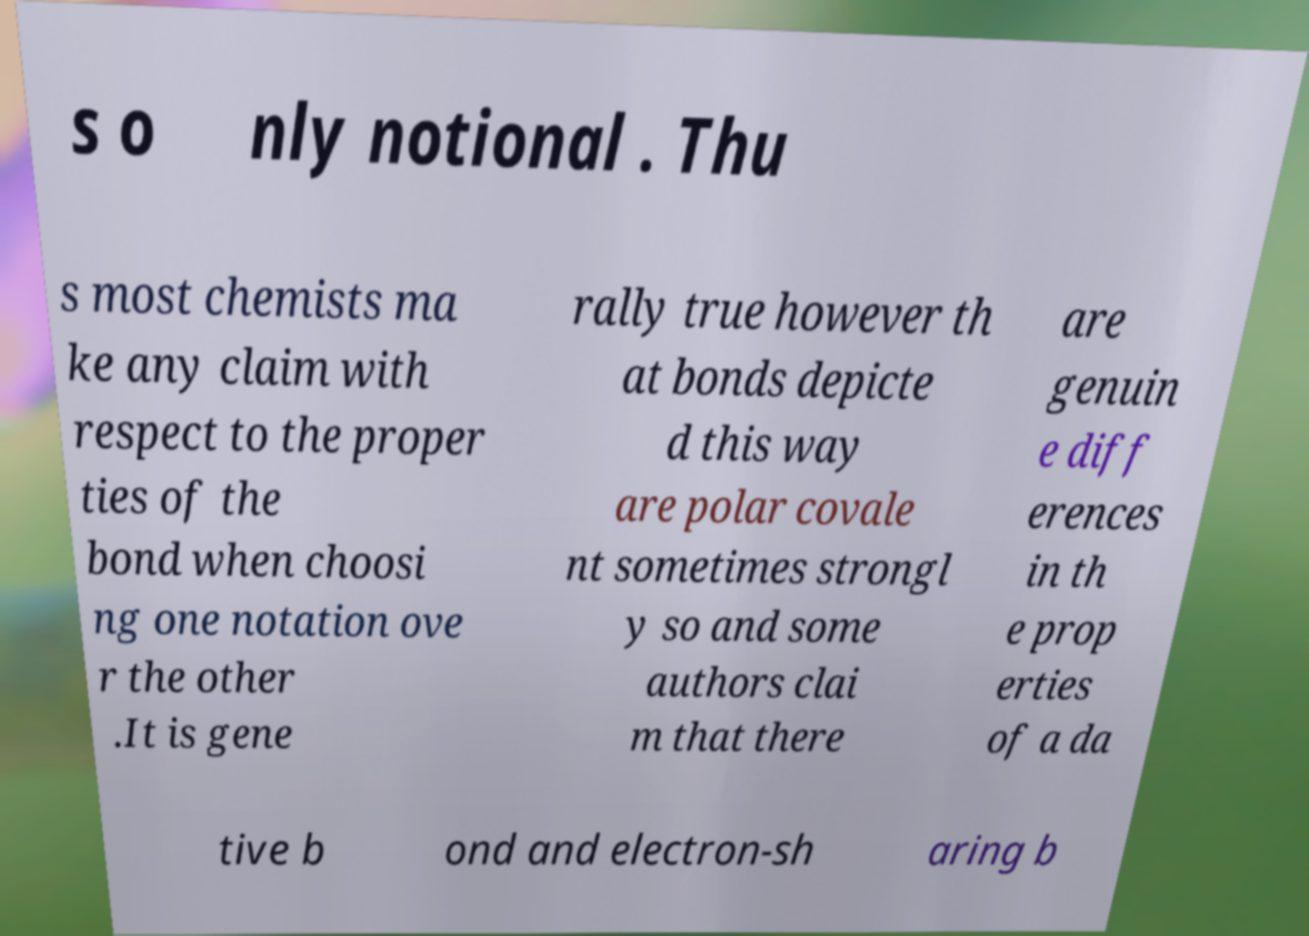For documentation purposes, I need the text within this image transcribed. Could you provide that? s o nly notional . Thu s most chemists ma ke any claim with respect to the proper ties of the bond when choosi ng one notation ove r the other .It is gene rally true however th at bonds depicte d this way are polar covale nt sometimes strongl y so and some authors clai m that there are genuin e diff erences in th e prop erties of a da tive b ond and electron-sh aring b 